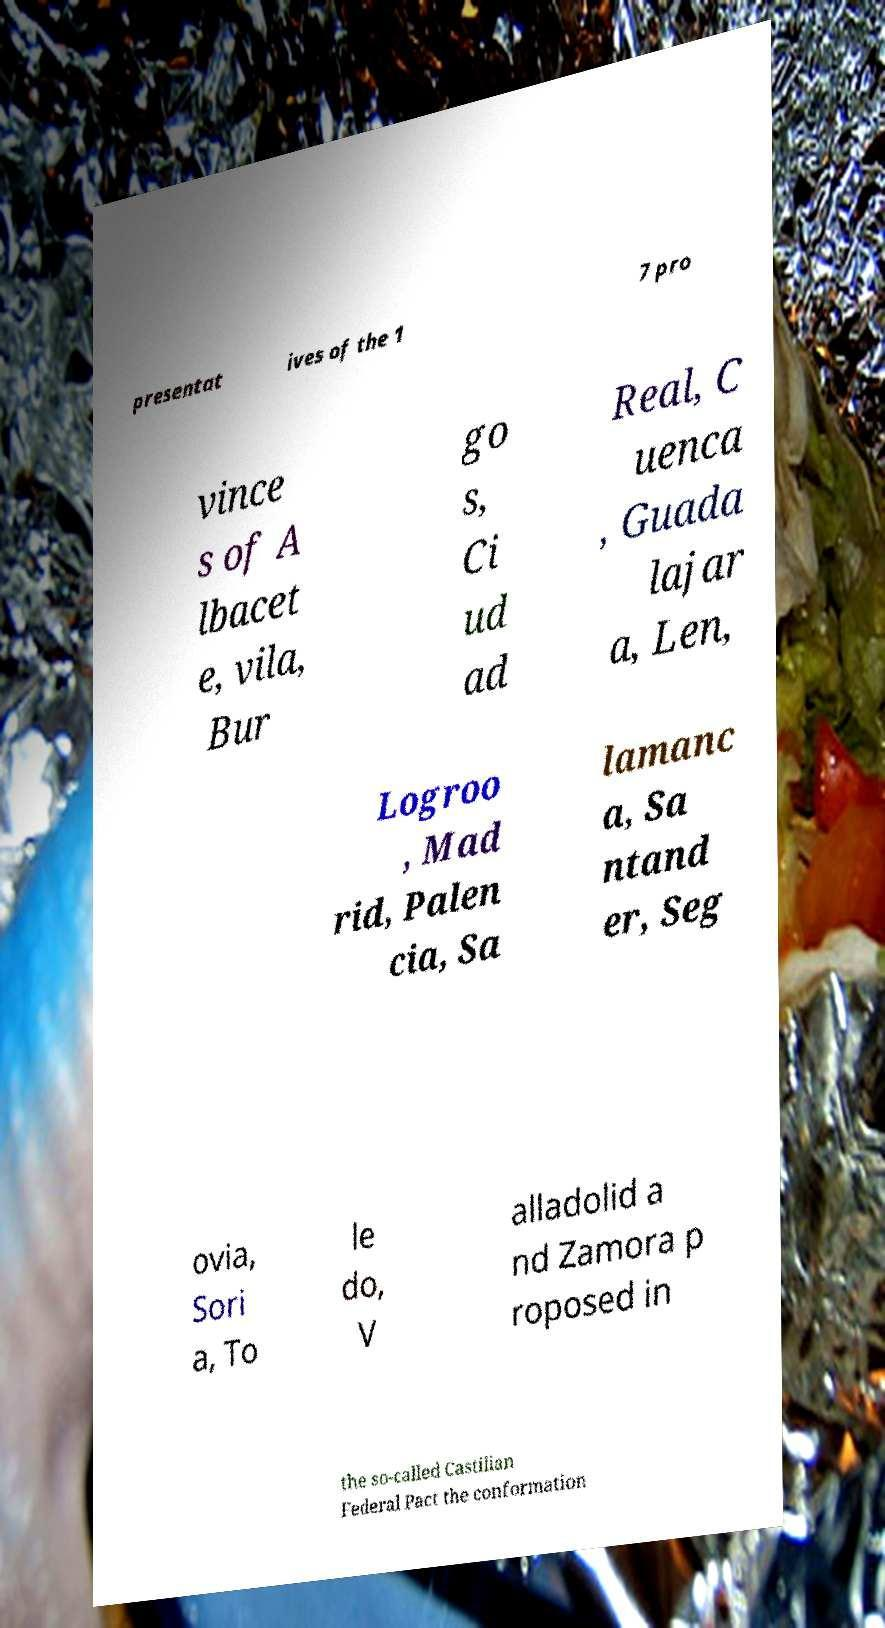Please read and relay the text visible in this image. What does it say? presentat ives of the 1 7 pro vince s of A lbacet e, vila, Bur go s, Ci ud ad Real, C uenca , Guada lajar a, Len, Logroo , Mad rid, Palen cia, Sa lamanc a, Sa ntand er, Seg ovia, Sori a, To le do, V alladolid a nd Zamora p roposed in the so-called Castilian Federal Pact the conformation 